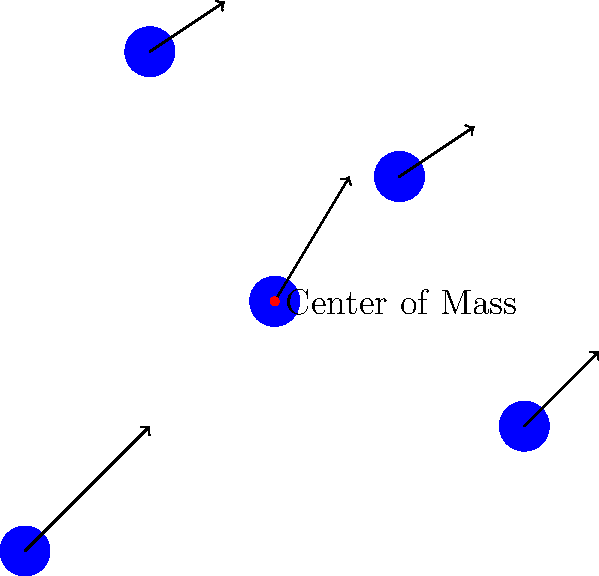In implementing a flocking behavior system for AI-controlled characters, which of the following rules is NOT typically considered one of the three basic rules of flocking as described by Craig Reynolds?

A) Separation: steer to avoid crowding local flockmates
B) Alignment: steer towards the average heading of local flockmates
C) Cohesion: steer to move towards the average position of local flockmates
D) Predation: steer to avoid nearby predators To answer this question, let's break down the basic rules of flocking behavior as described by Craig Reynolds:

1. Separation: This rule ensures that individual boids (bird-oid objects) maintain a minimum distance from other boids to prevent crowding. In the diagram, this would be represented by the boids not overlapping and maintaining some space between them.

2. Alignment: This rule steers boids towards the average heading of nearby flockmates. In the diagram, this is represented by the arrows showing similar directions for nearby boids.

3. Cohesion: This rule steers boids towards the average position (center of mass) of nearby flockmates. In the diagram, this is represented by the red dot labeled "Center of Mass," towards which the boids would tend to move.

4. Predation: While avoiding predators is an important behavior in many real-world scenarios, it is not one of the three basic rules of flocking as described by Craig Reynolds. This behavior would be considered an additional rule that could be added to enhance the realism of the simulation, but it's not part of the core flocking algorithm.

Therefore, the rule that is NOT typically considered one of the three basic rules of flocking is Predation.
Answer: D) Predation 